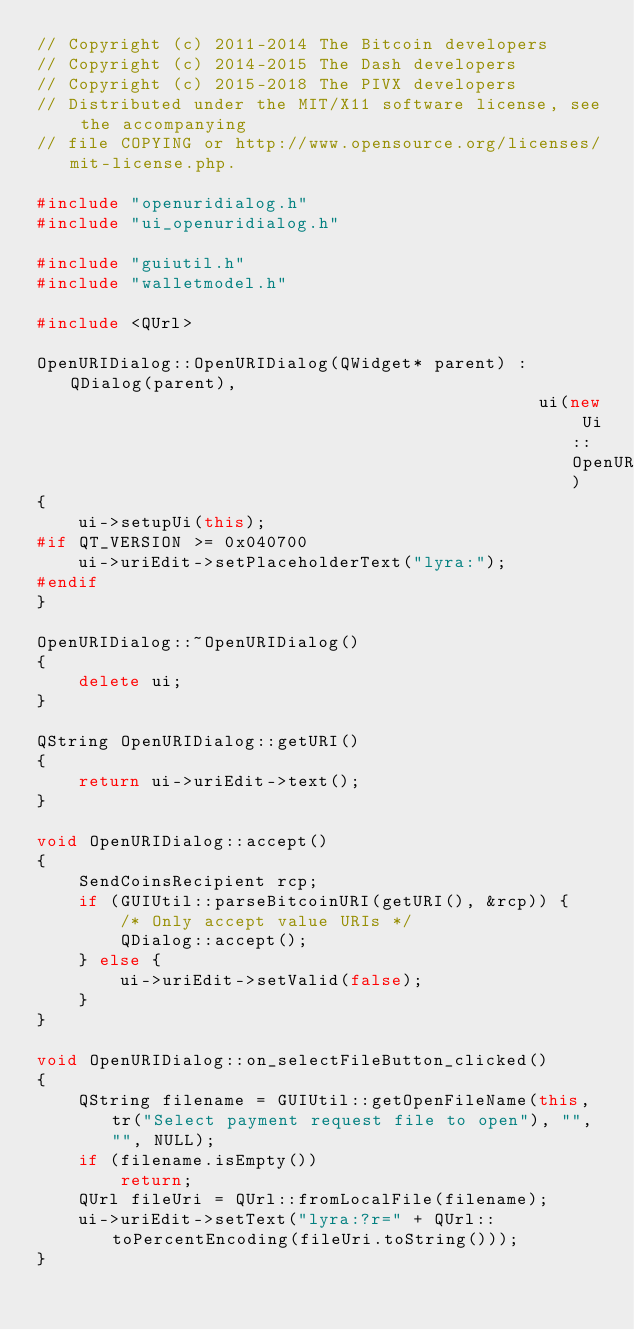<code> <loc_0><loc_0><loc_500><loc_500><_C++_>// Copyright (c) 2011-2014 The Bitcoin developers
// Copyright (c) 2014-2015 The Dash developers
// Copyright (c) 2015-2018 The PIVX developers
// Distributed under the MIT/X11 software license, see the accompanying
// file COPYING or http://www.opensource.org/licenses/mit-license.php.

#include "openuridialog.h"
#include "ui_openuridialog.h"

#include "guiutil.h"
#include "walletmodel.h"

#include <QUrl>

OpenURIDialog::OpenURIDialog(QWidget* parent) : QDialog(parent),
                                                ui(new Ui::OpenURIDialog)
{
    ui->setupUi(this);
#if QT_VERSION >= 0x040700
    ui->uriEdit->setPlaceholderText("lyra:");
#endif
}

OpenURIDialog::~OpenURIDialog()
{
    delete ui;
}

QString OpenURIDialog::getURI()
{
    return ui->uriEdit->text();
}

void OpenURIDialog::accept()
{
    SendCoinsRecipient rcp;
    if (GUIUtil::parseBitcoinURI(getURI(), &rcp)) {
        /* Only accept value URIs */
        QDialog::accept();
    } else {
        ui->uriEdit->setValid(false);
    }
}

void OpenURIDialog::on_selectFileButton_clicked()
{
    QString filename = GUIUtil::getOpenFileName(this, tr("Select payment request file to open"), "", "", NULL);
    if (filename.isEmpty())
        return;
    QUrl fileUri = QUrl::fromLocalFile(filename);
    ui->uriEdit->setText("lyra:?r=" + QUrl::toPercentEncoding(fileUri.toString()));
}
</code> 